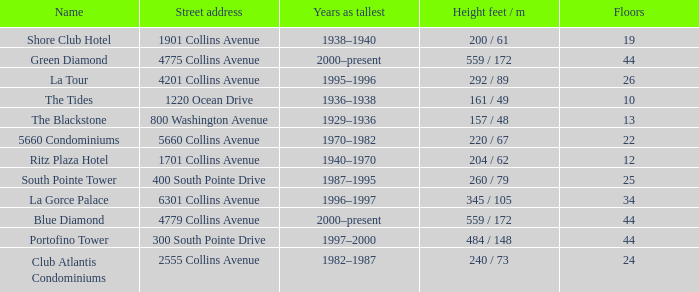How many years was the building with 24 floors the tallest? 1982–1987. 